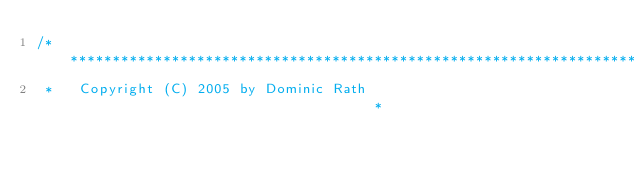Convert code to text. <code><loc_0><loc_0><loc_500><loc_500><_C_>/***************************************************************************
 *   Copyright (C) 2005 by Dominic Rath                                    *</code> 